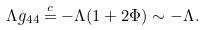Convert formula to latex. <formula><loc_0><loc_0><loc_500><loc_500>\Lambda g _ { 4 4 } \overset { c } { = } - \Lambda ( 1 + 2 \Phi ) \sim - \Lambda .</formula> 